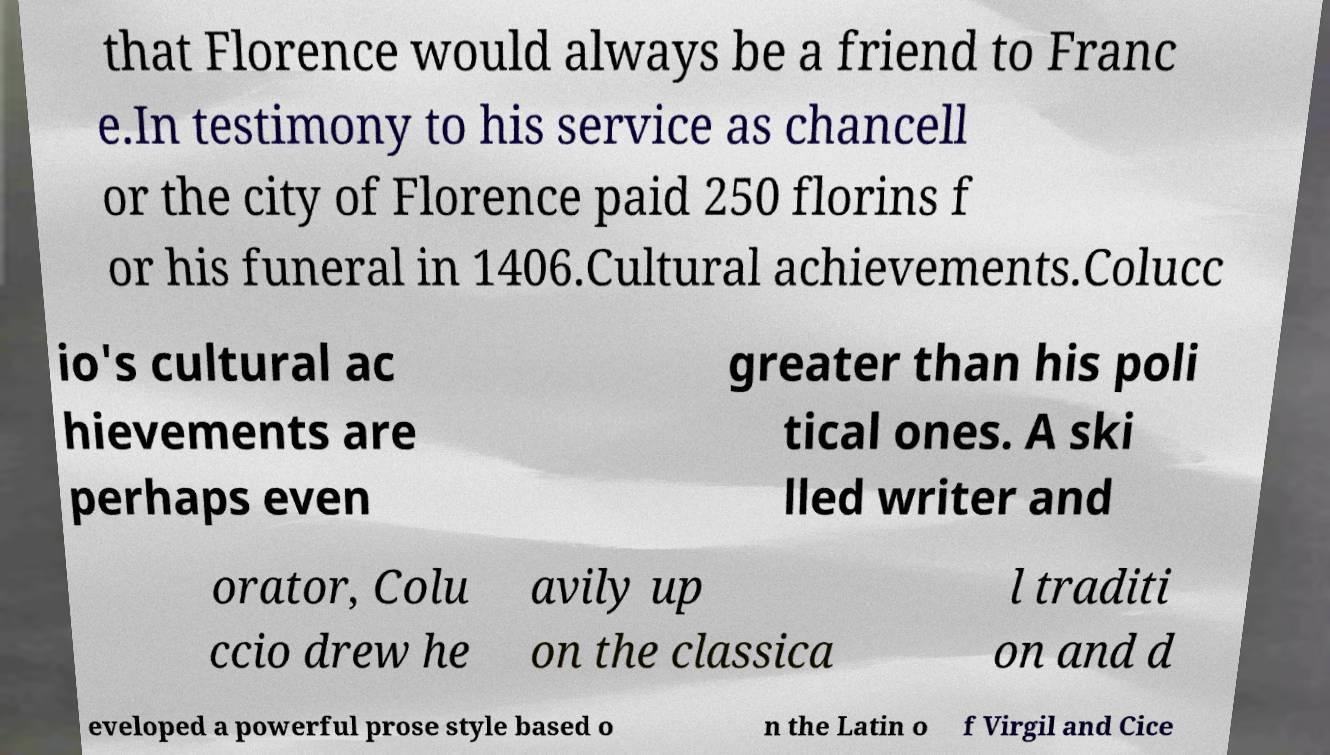There's text embedded in this image that I need extracted. Can you transcribe it verbatim? that Florence would always be a friend to Franc e.In testimony to his service as chancell or the city of Florence paid 250 florins f or his funeral in 1406.Cultural achievements.Colucc io's cultural ac hievements are perhaps even greater than his poli tical ones. A ski lled writer and orator, Colu ccio drew he avily up on the classica l traditi on and d eveloped a powerful prose style based o n the Latin o f Virgil and Cice 